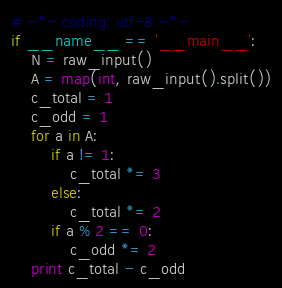Convert code to text. <code><loc_0><loc_0><loc_500><loc_500><_Python_># -*- coding: utf-8 -*-
if __name__ == '__main__':
    N = raw_input()
    A = map(int, raw_input().split())
    c_total = 1
    c_odd = 1
    for a in A:
        if a != 1:
            c_total *= 3
        else:
            c_total *= 2
        if a % 2 == 0:
            c_odd *= 2
    print c_total - c_odd
</code> 